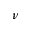Convert formula to latex. <formula><loc_0><loc_0><loc_500><loc_500>\nu</formula> 